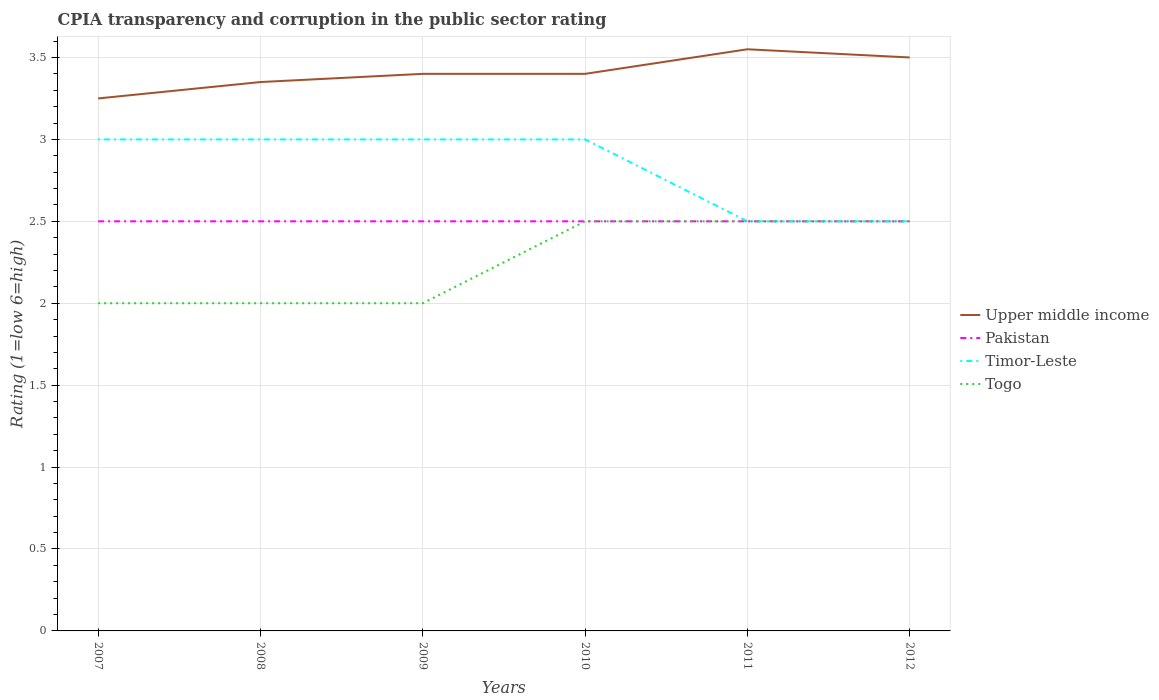How many different coloured lines are there?
Keep it short and to the point. 4. Is the number of lines equal to the number of legend labels?
Your answer should be very brief. Yes. Across all years, what is the maximum CPIA rating in Upper middle income?
Provide a succinct answer. 3.25. In which year was the CPIA rating in Timor-Leste maximum?
Your answer should be compact. 2011. What is the total CPIA rating in Pakistan in the graph?
Offer a very short reply. 0. What is the difference between the highest and the second highest CPIA rating in Pakistan?
Provide a short and direct response. 0. What is the difference between the highest and the lowest CPIA rating in Timor-Leste?
Your answer should be very brief. 4. Is the CPIA rating in Upper middle income strictly greater than the CPIA rating in Pakistan over the years?
Offer a terse response. No. How many years are there in the graph?
Offer a very short reply. 6. Are the values on the major ticks of Y-axis written in scientific E-notation?
Offer a terse response. No. Does the graph contain grids?
Your answer should be very brief. Yes. How many legend labels are there?
Your answer should be very brief. 4. What is the title of the graph?
Offer a very short reply. CPIA transparency and corruption in the public sector rating. Does "Cabo Verde" appear as one of the legend labels in the graph?
Give a very brief answer. No. What is the label or title of the Y-axis?
Your answer should be very brief. Rating (1=low 6=high). What is the Rating (1=low 6=high) in Togo in 2007?
Provide a succinct answer. 2. What is the Rating (1=low 6=high) of Upper middle income in 2008?
Your answer should be very brief. 3.35. What is the Rating (1=low 6=high) in Pakistan in 2008?
Keep it short and to the point. 2.5. What is the Rating (1=low 6=high) in Timor-Leste in 2008?
Ensure brevity in your answer.  3. What is the Rating (1=low 6=high) of Upper middle income in 2009?
Make the answer very short. 3.4. What is the Rating (1=low 6=high) in Togo in 2009?
Offer a terse response. 2. What is the Rating (1=low 6=high) in Upper middle income in 2010?
Keep it short and to the point. 3.4. What is the Rating (1=low 6=high) in Togo in 2010?
Provide a succinct answer. 2.5. What is the Rating (1=low 6=high) of Upper middle income in 2011?
Your response must be concise. 3.55. What is the Rating (1=low 6=high) in Pakistan in 2011?
Your response must be concise. 2.5. What is the Rating (1=low 6=high) in Timor-Leste in 2011?
Provide a succinct answer. 2.5. What is the Rating (1=low 6=high) in Togo in 2011?
Keep it short and to the point. 2.5. What is the Rating (1=low 6=high) in Upper middle income in 2012?
Ensure brevity in your answer.  3.5. What is the Rating (1=low 6=high) of Timor-Leste in 2012?
Your response must be concise. 2.5. Across all years, what is the maximum Rating (1=low 6=high) of Upper middle income?
Make the answer very short. 3.55. Across all years, what is the maximum Rating (1=low 6=high) of Pakistan?
Ensure brevity in your answer.  2.5. Across all years, what is the maximum Rating (1=low 6=high) in Togo?
Ensure brevity in your answer.  2.5. Across all years, what is the minimum Rating (1=low 6=high) of Upper middle income?
Provide a short and direct response. 3.25. Across all years, what is the minimum Rating (1=low 6=high) of Pakistan?
Your answer should be very brief. 2.5. Across all years, what is the minimum Rating (1=low 6=high) in Togo?
Your response must be concise. 2. What is the total Rating (1=low 6=high) in Upper middle income in the graph?
Offer a terse response. 20.45. What is the total Rating (1=low 6=high) of Pakistan in the graph?
Give a very brief answer. 15. What is the total Rating (1=low 6=high) of Timor-Leste in the graph?
Your answer should be very brief. 17. What is the total Rating (1=low 6=high) in Togo in the graph?
Keep it short and to the point. 13.5. What is the difference between the Rating (1=low 6=high) of Pakistan in 2007 and that in 2008?
Give a very brief answer. 0. What is the difference between the Rating (1=low 6=high) of Timor-Leste in 2007 and that in 2008?
Keep it short and to the point. 0. What is the difference between the Rating (1=low 6=high) of Togo in 2007 and that in 2008?
Give a very brief answer. 0. What is the difference between the Rating (1=low 6=high) in Timor-Leste in 2007 and that in 2009?
Make the answer very short. 0. What is the difference between the Rating (1=low 6=high) in Togo in 2007 and that in 2009?
Your answer should be compact. 0. What is the difference between the Rating (1=low 6=high) in Upper middle income in 2007 and that in 2010?
Give a very brief answer. -0.15. What is the difference between the Rating (1=low 6=high) in Timor-Leste in 2007 and that in 2010?
Your response must be concise. 0. What is the difference between the Rating (1=low 6=high) in Upper middle income in 2007 and that in 2012?
Provide a short and direct response. -0.25. What is the difference between the Rating (1=low 6=high) of Pakistan in 2007 and that in 2012?
Ensure brevity in your answer.  0. What is the difference between the Rating (1=low 6=high) of Togo in 2007 and that in 2012?
Give a very brief answer. -0.5. What is the difference between the Rating (1=low 6=high) of Pakistan in 2008 and that in 2009?
Provide a short and direct response. 0. What is the difference between the Rating (1=low 6=high) in Timor-Leste in 2008 and that in 2009?
Provide a succinct answer. 0. What is the difference between the Rating (1=low 6=high) of Upper middle income in 2008 and that in 2010?
Give a very brief answer. -0.05. What is the difference between the Rating (1=low 6=high) of Togo in 2008 and that in 2010?
Ensure brevity in your answer.  -0.5. What is the difference between the Rating (1=low 6=high) in Upper middle income in 2008 and that in 2011?
Make the answer very short. -0.2. What is the difference between the Rating (1=low 6=high) in Pakistan in 2008 and that in 2011?
Make the answer very short. 0. What is the difference between the Rating (1=low 6=high) in Togo in 2008 and that in 2011?
Provide a short and direct response. -0.5. What is the difference between the Rating (1=low 6=high) of Upper middle income in 2008 and that in 2012?
Offer a very short reply. -0.15. What is the difference between the Rating (1=low 6=high) of Timor-Leste in 2008 and that in 2012?
Offer a terse response. 0.5. What is the difference between the Rating (1=low 6=high) of Togo in 2008 and that in 2012?
Offer a very short reply. -0.5. What is the difference between the Rating (1=low 6=high) of Upper middle income in 2009 and that in 2012?
Keep it short and to the point. -0.1. What is the difference between the Rating (1=low 6=high) of Togo in 2009 and that in 2012?
Keep it short and to the point. -0.5. What is the difference between the Rating (1=low 6=high) in Pakistan in 2010 and that in 2011?
Ensure brevity in your answer.  0. What is the difference between the Rating (1=low 6=high) in Togo in 2010 and that in 2011?
Your answer should be compact. 0. What is the difference between the Rating (1=low 6=high) of Upper middle income in 2010 and that in 2012?
Your response must be concise. -0.1. What is the difference between the Rating (1=low 6=high) of Timor-Leste in 2010 and that in 2012?
Give a very brief answer. 0.5. What is the difference between the Rating (1=low 6=high) in Togo in 2011 and that in 2012?
Make the answer very short. 0. What is the difference between the Rating (1=low 6=high) of Upper middle income in 2007 and the Rating (1=low 6=high) of Pakistan in 2008?
Provide a short and direct response. 0.75. What is the difference between the Rating (1=low 6=high) in Pakistan in 2007 and the Rating (1=low 6=high) in Timor-Leste in 2008?
Offer a very short reply. -0.5. What is the difference between the Rating (1=low 6=high) in Pakistan in 2007 and the Rating (1=low 6=high) in Togo in 2008?
Offer a terse response. 0.5. What is the difference between the Rating (1=low 6=high) in Upper middle income in 2007 and the Rating (1=low 6=high) in Pakistan in 2009?
Offer a very short reply. 0.75. What is the difference between the Rating (1=low 6=high) in Upper middle income in 2007 and the Rating (1=low 6=high) in Togo in 2009?
Offer a very short reply. 1.25. What is the difference between the Rating (1=low 6=high) in Pakistan in 2007 and the Rating (1=low 6=high) in Timor-Leste in 2009?
Make the answer very short. -0.5. What is the difference between the Rating (1=low 6=high) in Pakistan in 2007 and the Rating (1=low 6=high) in Togo in 2009?
Make the answer very short. 0.5. What is the difference between the Rating (1=low 6=high) in Timor-Leste in 2007 and the Rating (1=low 6=high) in Togo in 2009?
Ensure brevity in your answer.  1. What is the difference between the Rating (1=low 6=high) in Upper middle income in 2007 and the Rating (1=low 6=high) in Togo in 2010?
Provide a succinct answer. 0.75. What is the difference between the Rating (1=low 6=high) in Pakistan in 2007 and the Rating (1=low 6=high) in Timor-Leste in 2010?
Provide a succinct answer. -0.5. What is the difference between the Rating (1=low 6=high) of Pakistan in 2007 and the Rating (1=low 6=high) of Togo in 2010?
Offer a terse response. 0. What is the difference between the Rating (1=low 6=high) in Upper middle income in 2007 and the Rating (1=low 6=high) in Pakistan in 2011?
Make the answer very short. 0.75. What is the difference between the Rating (1=low 6=high) of Upper middle income in 2007 and the Rating (1=low 6=high) of Togo in 2011?
Your answer should be very brief. 0.75. What is the difference between the Rating (1=low 6=high) in Pakistan in 2007 and the Rating (1=low 6=high) in Timor-Leste in 2011?
Offer a terse response. 0. What is the difference between the Rating (1=low 6=high) in Timor-Leste in 2007 and the Rating (1=low 6=high) in Togo in 2011?
Make the answer very short. 0.5. What is the difference between the Rating (1=low 6=high) in Upper middle income in 2007 and the Rating (1=low 6=high) in Pakistan in 2012?
Ensure brevity in your answer.  0.75. What is the difference between the Rating (1=low 6=high) of Pakistan in 2007 and the Rating (1=low 6=high) of Timor-Leste in 2012?
Make the answer very short. 0. What is the difference between the Rating (1=low 6=high) in Upper middle income in 2008 and the Rating (1=low 6=high) in Togo in 2009?
Your answer should be very brief. 1.35. What is the difference between the Rating (1=low 6=high) in Upper middle income in 2008 and the Rating (1=low 6=high) in Pakistan in 2010?
Provide a short and direct response. 0.85. What is the difference between the Rating (1=low 6=high) in Upper middle income in 2008 and the Rating (1=low 6=high) in Timor-Leste in 2010?
Make the answer very short. 0.35. What is the difference between the Rating (1=low 6=high) in Pakistan in 2008 and the Rating (1=low 6=high) in Timor-Leste in 2010?
Keep it short and to the point. -0.5. What is the difference between the Rating (1=low 6=high) of Pakistan in 2008 and the Rating (1=low 6=high) of Togo in 2010?
Offer a very short reply. 0. What is the difference between the Rating (1=low 6=high) in Upper middle income in 2008 and the Rating (1=low 6=high) in Pakistan in 2011?
Your answer should be very brief. 0.85. What is the difference between the Rating (1=low 6=high) of Upper middle income in 2008 and the Rating (1=low 6=high) of Pakistan in 2012?
Offer a very short reply. 0.85. What is the difference between the Rating (1=low 6=high) of Upper middle income in 2008 and the Rating (1=low 6=high) of Togo in 2012?
Provide a succinct answer. 0.85. What is the difference between the Rating (1=low 6=high) in Pakistan in 2008 and the Rating (1=low 6=high) in Timor-Leste in 2012?
Your answer should be very brief. 0. What is the difference between the Rating (1=low 6=high) in Upper middle income in 2009 and the Rating (1=low 6=high) in Pakistan in 2010?
Give a very brief answer. 0.9. What is the difference between the Rating (1=low 6=high) in Timor-Leste in 2009 and the Rating (1=low 6=high) in Togo in 2010?
Your answer should be compact. 0.5. What is the difference between the Rating (1=low 6=high) of Upper middle income in 2009 and the Rating (1=low 6=high) of Togo in 2011?
Your answer should be compact. 0.9. What is the difference between the Rating (1=low 6=high) of Pakistan in 2009 and the Rating (1=low 6=high) of Timor-Leste in 2011?
Provide a succinct answer. 0. What is the difference between the Rating (1=low 6=high) in Upper middle income in 2009 and the Rating (1=low 6=high) in Pakistan in 2012?
Your response must be concise. 0.9. What is the difference between the Rating (1=low 6=high) in Upper middle income in 2009 and the Rating (1=low 6=high) in Togo in 2012?
Your answer should be compact. 0.9. What is the difference between the Rating (1=low 6=high) of Pakistan in 2009 and the Rating (1=low 6=high) of Timor-Leste in 2012?
Your answer should be compact. 0. What is the difference between the Rating (1=low 6=high) of Timor-Leste in 2009 and the Rating (1=low 6=high) of Togo in 2012?
Provide a short and direct response. 0.5. What is the difference between the Rating (1=low 6=high) of Upper middle income in 2010 and the Rating (1=low 6=high) of Timor-Leste in 2011?
Offer a very short reply. 0.9. What is the difference between the Rating (1=low 6=high) in Timor-Leste in 2010 and the Rating (1=low 6=high) in Togo in 2011?
Offer a terse response. 0.5. What is the difference between the Rating (1=low 6=high) of Pakistan in 2010 and the Rating (1=low 6=high) of Timor-Leste in 2012?
Your answer should be very brief. 0. What is the difference between the Rating (1=low 6=high) in Upper middle income in 2011 and the Rating (1=low 6=high) in Pakistan in 2012?
Offer a terse response. 1.05. What is the difference between the Rating (1=low 6=high) in Pakistan in 2011 and the Rating (1=low 6=high) in Togo in 2012?
Ensure brevity in your answer.  0. What is the average Rating (1=low 6=high) of Upper middle income per year?
Ensure brevity in your answer.  3.41. What is the average Rating (1=low 6=high) in Timor-Leste per year?
Make the answer very short. 2.83. What is the average Rating (1=low 6=high) in Togo per year?
Provide a succinct answer. 2.25. In the year 2007, what is the difference between the Rating (1=low 6=high) in Upper middle income and Rating (1=low 6=high) in Timor-Leste?
Make the answer very short. 0.25. In the year 2007, what is the difference between the Rating (1=low 6=high) of Upper middle income and Rating (1=low 6=high) of Togo?
Your answer should be very brief. 1.25. In the year 2007, what is the difference between the Rating (1=low 6=high) in Timor-Leste and Rating (1=low 6=high) in Togo?
Give a very brief answer. 1. In the year 2008, what is the difference between the Rating (1=low 6=high) in Upper middle income and Rating (1=low 6=high) in Pakistan?
Keep it short and to the point. 0.85. In the year 2008, what is the difference between the Rating (1=low 6=high) in Upper middle income and Rating (1=low 6=high) in Timor-Leste?
Provide a succinct answer. 0.35. In the year 2008, what is the difference between the Rating (1=low 6=high) of Upper middle income and Rating (1=low 6=high) of Togo?
Give a very brief answer. 1.35. In the year 2008, what is the difference between the Rating (1=low 6=high) of Timor-Leste and Rating (1=low 6=high) of Togo?
Keep it short and to the point. 1. In the year 2009, what is the difference between the Rating (1=low 6=high) in Upper middle income and Rating (1=low 6=high) in Pakistan?
Give a very brief answer. 0.9. In the year 2009, what is the difference between the Rating (1=low 6=high) of Upper middle income and Rating (1=low 6=high) of Togo?
Offer a very short reply. 1.4. In the year 2009, what is the difference between the Rating (1=low 6=high) of Pakistan and Rating (1=low 6=high) of Timor-Leste?
Provide a succinct answer. -0.5. In the year 2009, what is the difference between the Rating (1=low 6=high) of Pakistan and Rating (1=low 6=high) of Togo?
Offer a very short reply. 0.5. In the year 2009, what is the difference between the Rating (1=low 6=high) in Timor-Leste and Rating (1=low 6=high) in Togo?
Offer a very short reply. 1. In the year 2010, what is the difference between the Rating (1=low 6=high) in Timor-Leste and Rating (1=low 6=high) in Togo?
Your answer should be very brief. 0.5. In the year 2011, what is the difference between the Rating (1=low 6=high) in Upper middle income and Rating (1=low 6=high) in Pakistan?
Give a very brief answer. 1.05. In the year 2011, what is the difference between the Rating (1=low 6=high) of Upper middle income and Rating (1=low 6=high) of Timor-Leste?
Offer a terse response. 1.05. In the year 2012, what is the difference between the Rating (1=low 6=high) of Upper middle income and Rating (1=low 6=high) of Pakistan?
Provide a succinct answer. 1. In the year 2012, what is the difference between the Rating (1=low 6=high) in Pakistan and Rating (1=low 6=high) in Togo?
Your answer should be compact. 0. What is the ratio of the Rating (1=low 6=high) in Upper middle income in 2007 to that in 2008?
Offer a terse response. 0.97. What is the ratio of the Rating (1=low 6=high) in Upper middle income in 2007 to that in 2009?
Give a very brief answer. 0.96. What is the ratio of the Rating (1=low 6=high) in Pakistan in 2007 to that in 2009?
Make the answer very short. 1. What is the ratio of the Rating (1=low 6=high) of Timor-Leste in 2007 to that in 2009?
Offer a very short reply. 1. What is the ratio of the Rating (1=low 6=high) in Upper middle income in 2007 to that in 2010?
Make the answer very short. 0.96. What is the ratio of the Rating (1=low 6=high) in Pakistan in 2007 to that in 2010?
Provide a short and direct response. 1. What is the ratio of the Rating (1=low 6=high) of Timor-Leste in 2007 to that in 2010?
Your response must be concise. 1. What is the ratio of the Rating (1=low 6=high) in Upper middle income in 2007 to that in 2011?
Provide a short and direct response. 0.92. What is the ratio of the Rating (1=low 6=high) of Pakistan in 2007 to that in 2011?
Your answer should be very brief. 1. What is the ratio of the Rating (1=low 6=high) of Timor-Leste in 2007 to that in 2011?
Your answer should be very brief. 1.2. What is the ratio of the Rating (1=low 6=high) of Togo in 2007 to that in 2011?
Provide a succinct answer. 0.8. What is the ratio of the Rating (1=low 6=high) in Upper middle income in 2007 to that in 2012?
Your response must be concise. 0.93. What is the ratio of the Rating (1=low 6=high) in Pakistan in 2007 to that in 2012?
Keep it short and to the point. 1. What is the ratio of the Rating (1=low 6=high) of Timor-Leste in 2007 to that in 2012?
Offer a terse response. 1.2. What is the ratio of the Rating (1=low 6=high) in Togo in 2007 to that in 2012?
Offer a very short reply. 0.8. What is the ratio of the Rating (1=low 6=high) of Pakistan in 2008 to that in 2009?
Provide a succinct answer. 1. What is the ratio of the Rating (1=low 6=high) of Timor-Leste in 2008 to that in 2010?
Give a very brief answer. 1. What is the ratio of the Rating (1=low 6=high) in Togo in 2008 to that in 2010?
Provide a succinct answer. 0.8. What is the ratio of the Rating (1=low 6=high) of Upper middle income in 2008 to that in 2011?
Your answer should be compact. 0.94. What is the ratio of the Rating (1=low 6=high) in Togo in 2008 to that in 2011?
Provide a succinct answer. 0.8. What is the ratio of the Rating (1=low 6=high) of Upper middle income in 2008 to that in 2012?
Provide a succinct answer. 0.96. What is the ratio of the Rating (1=low 6=high) in Pakistan in 2009 to that in 2010?
Your response must be concise. 1. What is the ratio of the Rating (1=low 6=high) of Upper middle income in 2009 to that in 2011?
Offer a terse response. 0.96. What is the ratio of the Rating (1=low 6=high) of Pakistan in 2009 to that in 2011?
Your answer should be very brief. 1. What is the ratio of the Rating (1=low 6=high) in Upper middle income in 2009 to that in 2012?
Offer a terse response. 0.97. What is the ratio of the Rating (1=low 6=high) of Timor-Leste in 2009 to that in 2012?
Your answer should be compact. 1.2. What is the ratio of the Rating (1=low 6=high) of Upper middle income in 2010 to that in 2011?
Provide a succinct answer. 0.96. What is the ratio of the Rating (1=low 6=high) in Timor-Leste in 2010 to that in 2011?
Make the answer very short. 1.2. What is the ratio of the Rating (1=low 6=high) of Upper middle income in 2010 to that in 2012?
Your answer should be compact. 0.97. What is the ratio of the Rating (1=low 6=high) of Timor-Leste in 2010 to that in 2012?
Your answer should be very brief. 1.2. What is the ratio of the Rating (1=low 6=high) in Upper middle income in 2011 to that in 2012?
Your answer should be very brief. 1.01. What is the ratio of the Rating (1=low 6=high) of Togo in 2011 to that in 2012?
Your answer should be very brief. 1. What is the difference between the highest and the second highest Rating (1=low 6=high) in Timor-Leste?
Keep it short and to the point. 0. What is the difference between the highest and the lowest Rating (1=low 6=high) of Upper middle income?
Make the answer very short. 0.3. What is the difference between the highest and the lowest Rating (1=low 6=high) in Pakistan?
Give a very brief answer. 0. What is the difference between the highest and the lowest Rating (1=low 6=high) of Togo?
Your answer should be very brief. 0.5. 